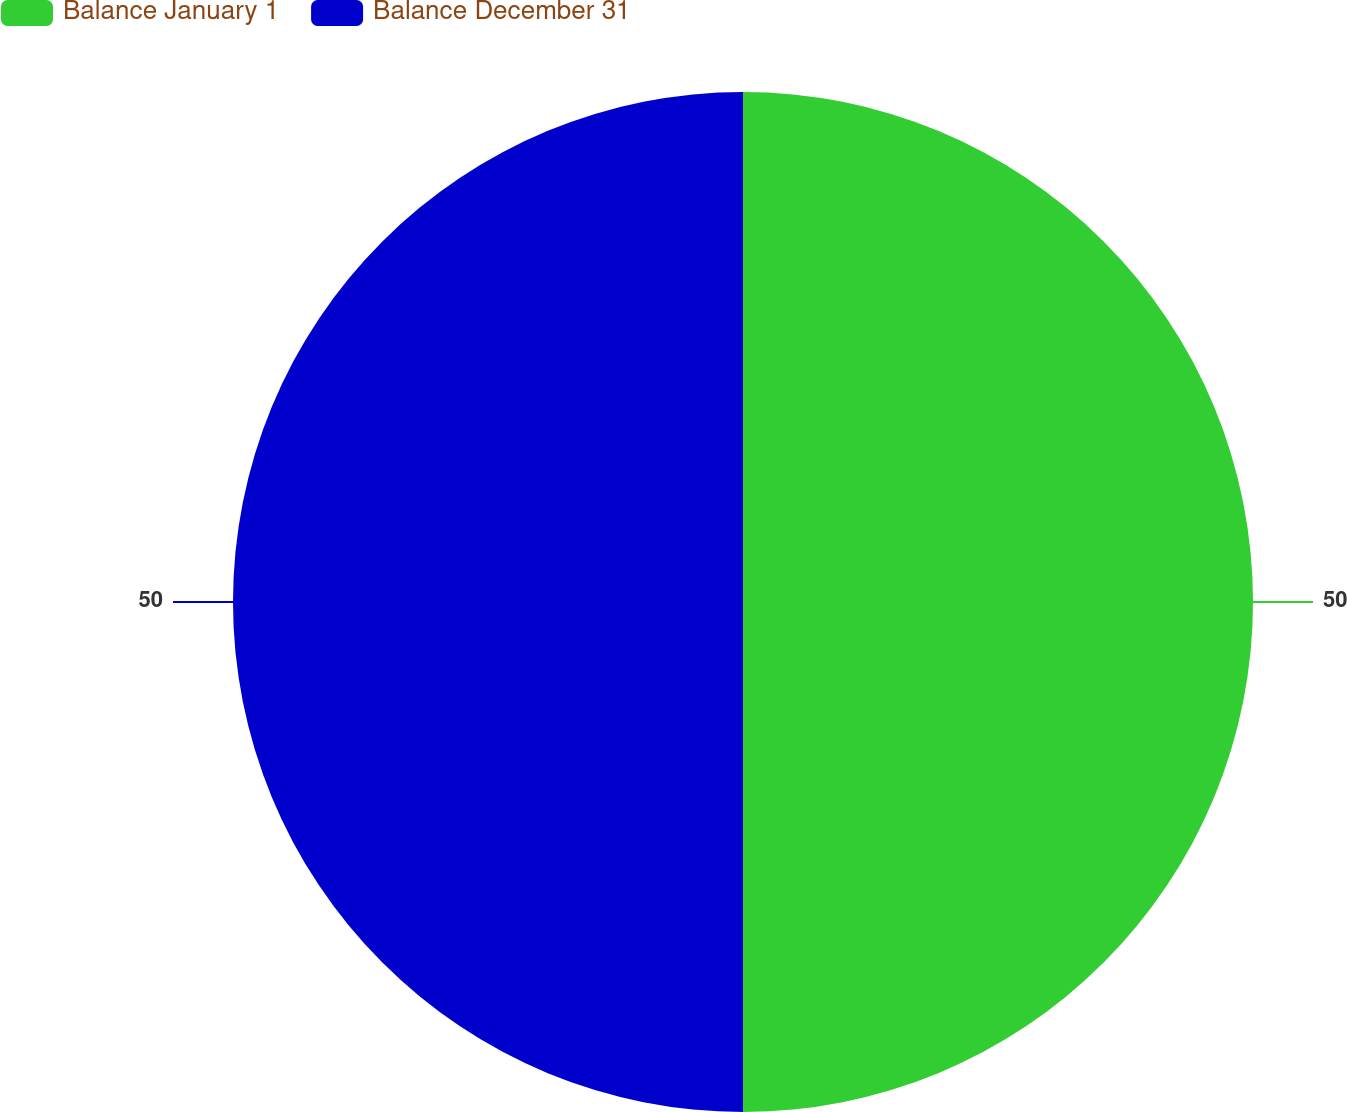Convert chart to OTSL. <chart><loc_0><loc_0><loc_500><loc_500><pie_chart><fcel>Balance January 1<fcel>Balance December 31<nl><fcel>50.0%<fcel>50.0%<nl></chart> 